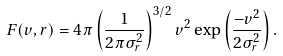<formula> <loc_0><loc_0><loc_500><loc_500>F ( v , r ) = 4 \pi \left ( \frac { 1 } { 2 \pi \sigma ^ { 2 } _ { r } } \right ) ^ { 3 / 2 } v ^ { 2 } \exp \left ( \frac { - v ^ { 2 } } { 2 \sigma ^ { 2 } _ { r } } \right ) .</formula> 